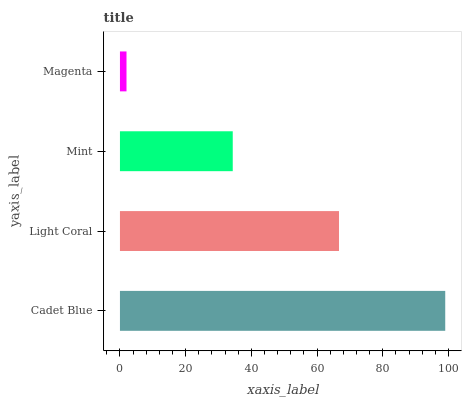Is Magenta the minimum?
Answer yes or no. Yes. Is Cadet Blue the maximum?
Answer yes or no. Yes. Is Light Coral the minimum?
Answer yes or no. No. Is Light Coral the maximum?
Answer yes or no. No. Is Cadet Blue greater than Light Coral?
Answer yes or no. Yes. Is Light Coral less than Cadet Blue?
Answer yes or no. Yes. Is Light Coral greater than Cadet Blue?
Answer yes or no. No. Is Cadet Blue less than Light Coral?
Answer yes or no. No. Is Light Coral the high median?
Answer yes or no. Yes. Is Mint the low median?
Answer yes or no. Yes. Is Mint the high median?
Answer yes or no. No. Is Cadet Blue the low median?
Answer yes or no. No. 